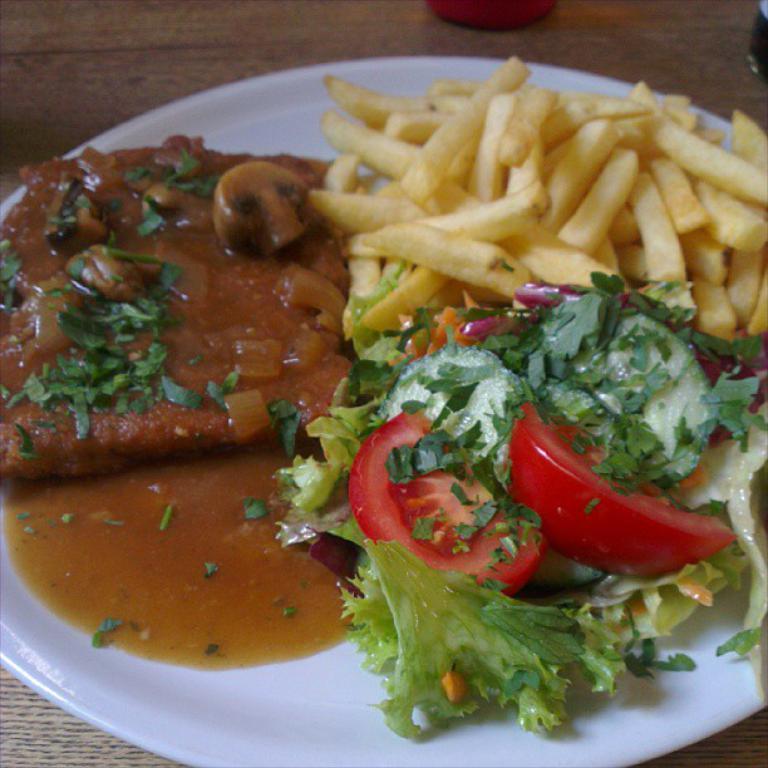Describe this image in one or two sentences. In this image I can see there are food items in a white color plate. 